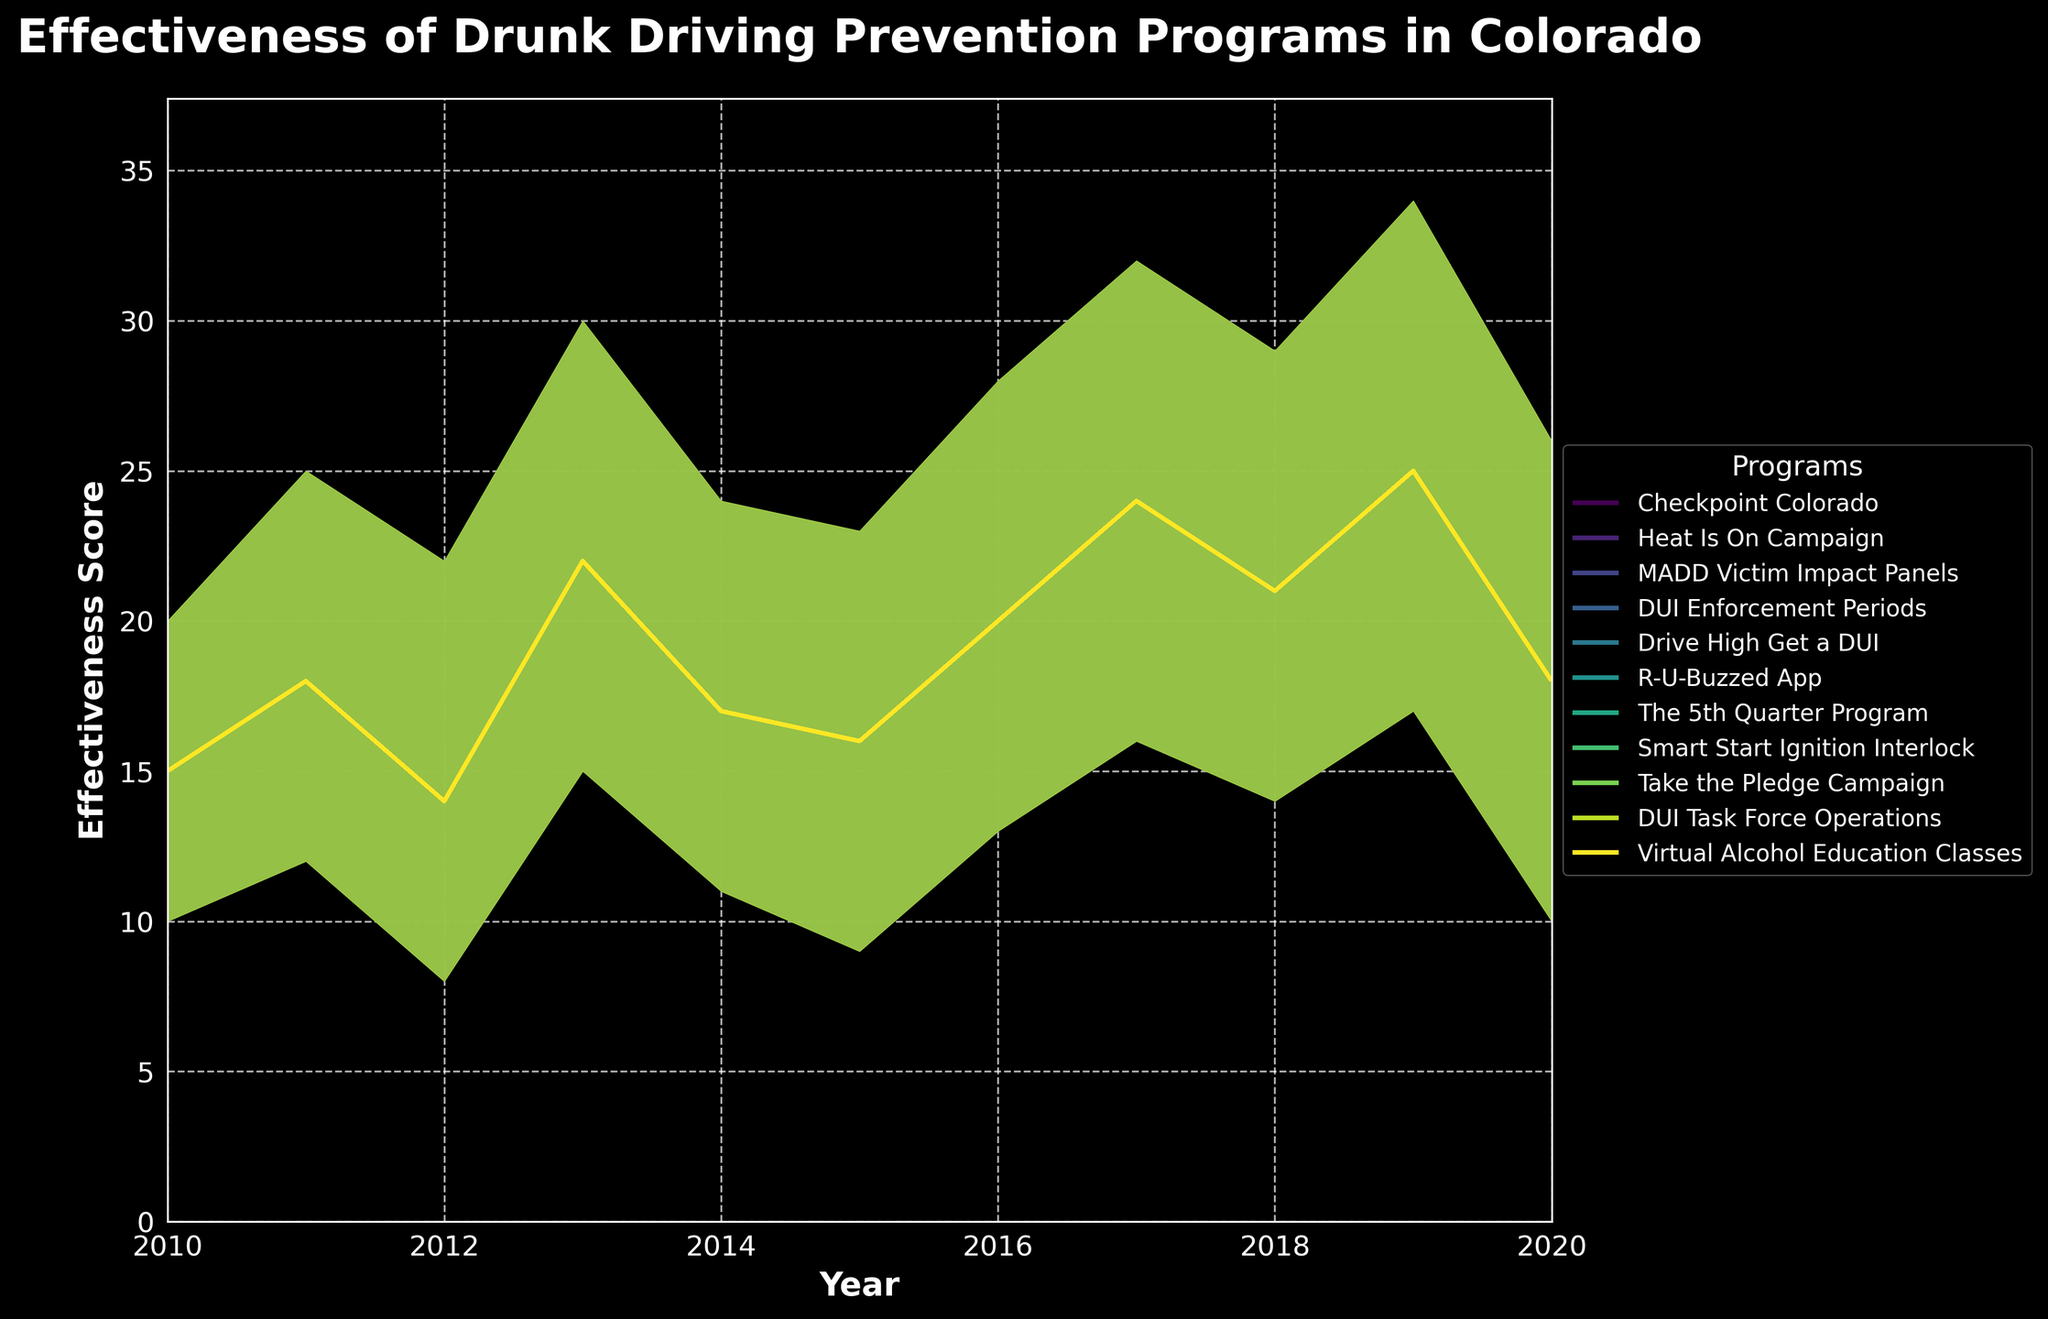What's the title of the figure? The title is displayed at the top of the figure.
Answer: Effectiveness of Drunk Driving Prevention Programs in Colorado What's the label for the vertical axis? The label for the vertical axis is shown along the y-axis of the figure.
Answer: Effectiveness Score Which program shows the highest average effectiveness in 2019? Identify the effectiveness scores for all programs in 2019, calculate the average (medium) scores, and find the highest. DUI Task Force Operations has 25 in the medium score category.
Answer: DUI Task Force Operations How many programs are compared in this figure? Each distinct color and label in the legend represents a different program. Count these entries.
Answer: 11 Which program had the lowest maximum effectiveness in 2012? Look for 2012, pick the data points with the highest effectiveness (high) score for that year, and find which is the smallest.
Answer: MADD Victim Impact Panels Is the effectiveness trend for the 'Smart Start Ignition Interlock' program increasing, decreasing, or stable over time? Follow the medium effectiveness values for 'Smart Start Ignition Interlock' from its start to end year. If it increases, it is increasing; if lower, decreasing; if it stays the same, stable. The values show 24 → 32.
Answer: Increasing What's the average medium effectiveness score of all programs in 2014? Find medium effectiveness values for each program for 2014 and calculate the average. (17) / 1 program = 17.
Answer: 17 Between 2013 and 2017, which had a greater increase in effectiveness, 'DUI Enforcement Periods' or 'Smart Start Ignition Interlock'? Look at the change in medium effectiveness for both programs: 'DUI Enforcement Periods' from 22 to 24, 'Smart Start Ignition Interlock' from 22 to 24 + 8 = 32. Difference for 'DUI Enforcement Periods' is 0; for 'Smart Start Ignition Interlock' is 8.
Answer: Smart Start Ignition Interlock Which program shows the widest range of effectiveness in 2018? For 2018, calculate the difference between high and low scores for each program. Identify the one with the largest difference (29-14 for 'Take the Pledge Campaign').
Answer: Take the Pledge Campaign 